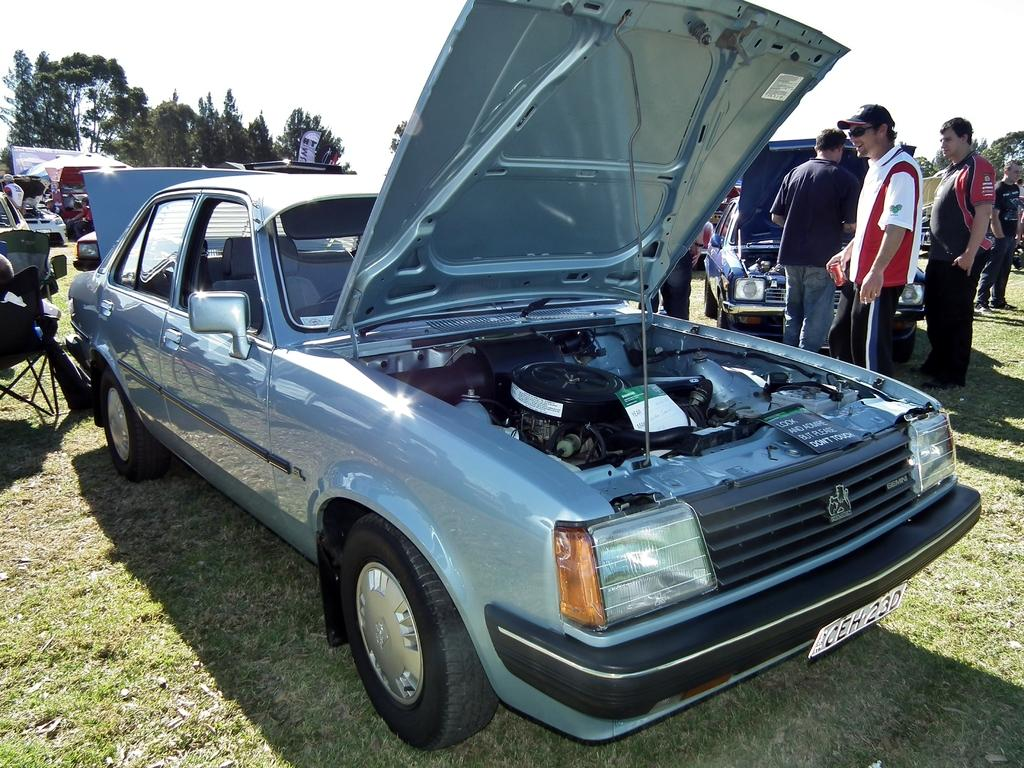What types of objects can be seen in the image? There are vehicles and people in the image. Where are the vehicles and people located? They are on the ground in the image. What can be seen in the background of the image? There are trees and the sky visible in the background. What type of yarn is being used to create the jail in the image? There is no jail or yarn present in the image. 